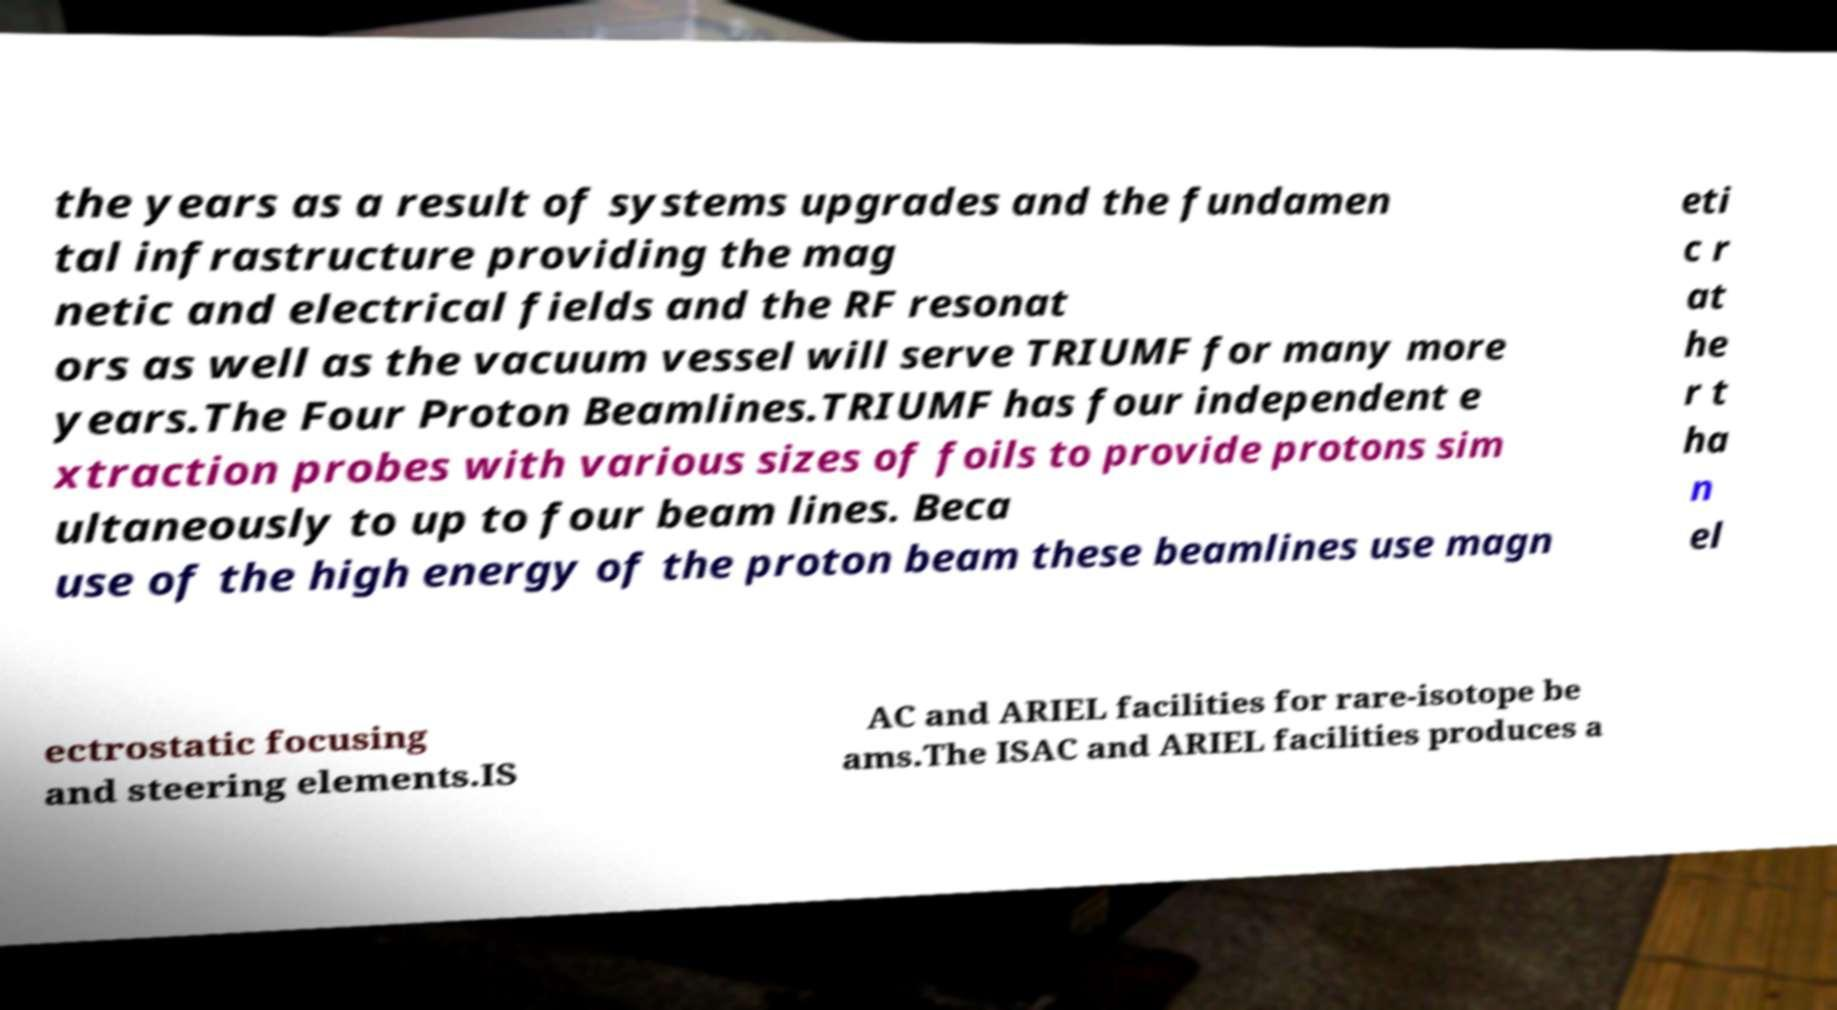Can you accurately transcribe the text from the provided image for me? the years as a result of systems upgrades and the fundamen tal infrastructure providing the mag netic and electrical fields and the RF resonat ors as well as the vacuum vessel will serve TRIUMF for many more years.The Four Proton Beamlines.TRIUMF has four independent e xtraction probes with various sizes of foils to provide protons sim ultaneously to up to four beam lines. Beca use of the high energy of the proton beam these beamlines use magn eti c r at he r t ha n el ectrostatic focusing and steering elements.IS AC and ARIEL facilities for rare-isotope be ams.The ISAC and ARIEL facilities produces a 